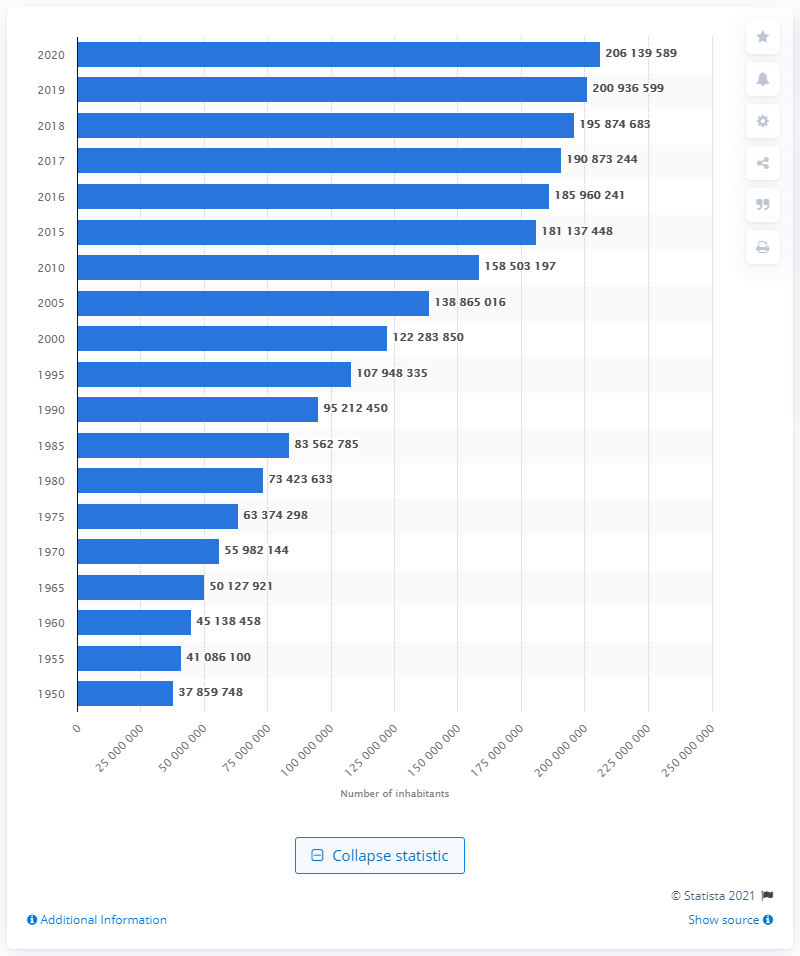Draw attention to some important aspects in this diagram. Nigeria's population in 2020 was approximately 206,139,589. 